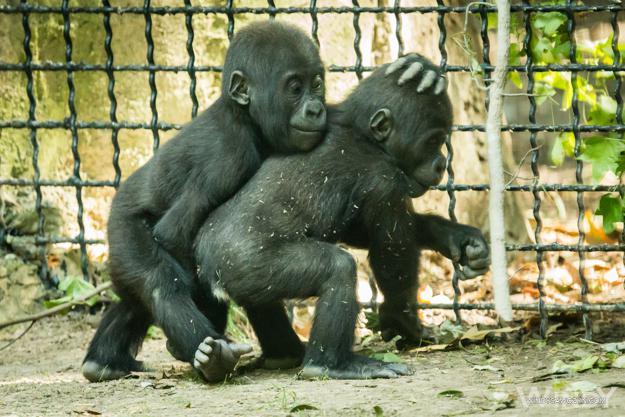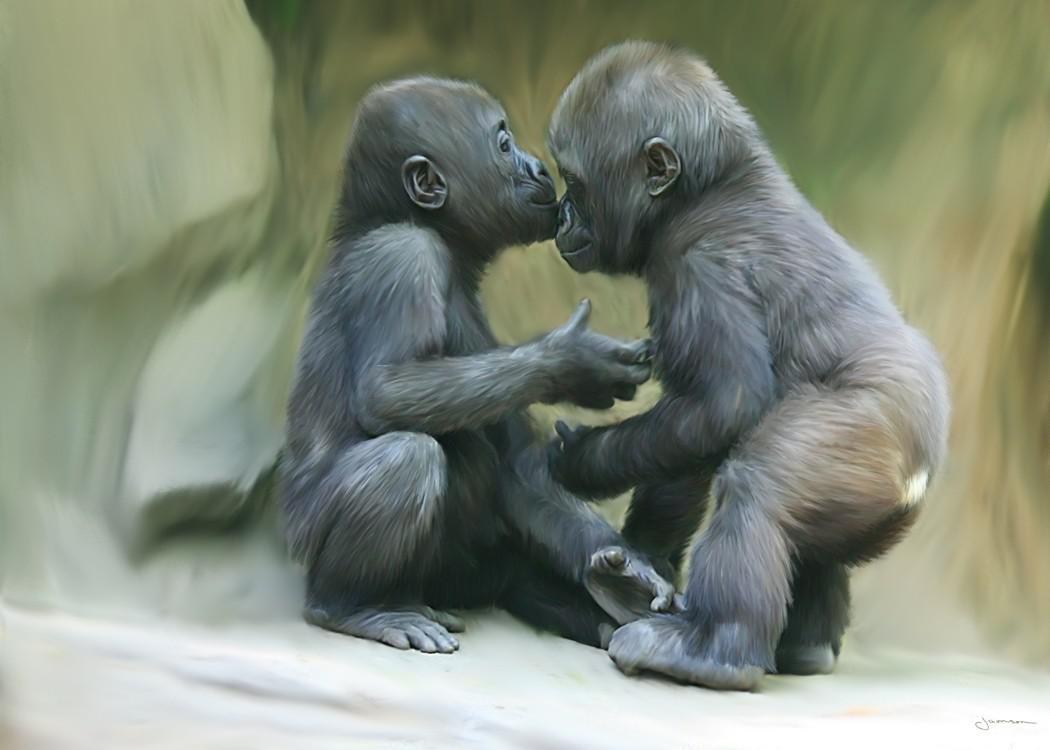The first image is the image on the left, the second image is the image on the right. Evaluate the accuracy of this statement regarding the images: "An image shows two gorillas of similar size posed close together, with bodies facing each other.". Is it true? Answer yes or no. Yes. The first image is the image on the left, the second image is the image on the right. For the images shown, is this caption "There are four gorillas with two pairs touching one another." true? Answer yes or no. Yes. 